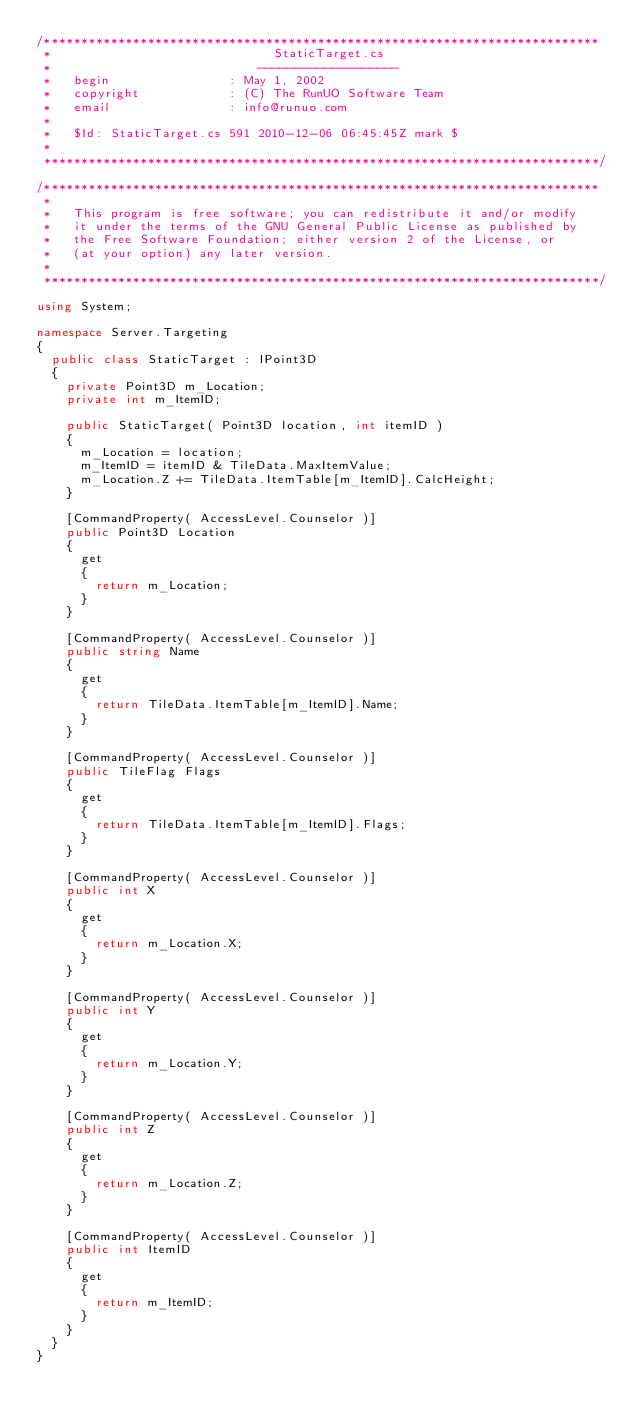<code> <loc_0><loc_0><loc_500><loc_500><_C#_>/***************************************************************************
 *                              StaticTarget.cs
 *                            -------------------
 *   begin                : May 1, 2002
 *   copyright            : (C) The RunUO Software Team
 *   email                : info@runuo.com
 *
 *   $Id: StaticTarget.cs 591 2010-12-06 06:45:45Z mark $
 *
 ***************************************************************************/

/***************************************************************************
 *
 *   This program is free software; you can redistribute it and/or modify
 *   it under the terms of the GNU General Public License as published by
 *   the Free Software Foundation; either version 2 of the License, or
 *   (at your option) any later version.
 *
 ***************************************************************************/

using System;

namespace Server.Targeting
{
	public class StaticTarget : IPoint3D
	{
		private Point3D m_Location;
		private int m_ItemID;

		public StaticTarget( Point3D location, int itemID )
		{
			m_Location = location;
			m_ItemID = itemID & TileData.MaxItemValue;
			m_Location.Z += TileData.ItemTable[m_ItemID].CalcHeight;
		}

		[CommandProperty( AccessLevel.Counselor )]
		public Point3D Location
		{
			get
			{
				return m_Location;
			}
		}

		[CommandProperty( AccessLevel.Counselor )]
		public string Name
		{
			get
			{
				return TileData.ItemTable[m_ItemID].Name;
			}
		}

		[CommandProperty( AccessLevel.Counselor )]
		public TileFlag Flags
		{
			get
			{
				return TileData.ItemTable[m_ItemID].Flags;
			}
		}

		[CommandProperty( AccessLevel.Counselor )]
		public int X
		{
			get
			{
				return m_Location.X;
			}
		}

		[CommandProperty( AccessLevel.Counselor )]
		public int Y
		{
			get
			{
				return m_Location.Y;
			}
		}

		[CommandProperty( AccessLevel.Counselor )]
		public int Z
		{
			get
			{
				return m_Location.Z;
			}
		}

		[CommandProperty( AccessLevel.Counselor )]
		public int ItemID
		{
			get
			{
				return m_ItemID;
			}
		}
	}
}</code> 